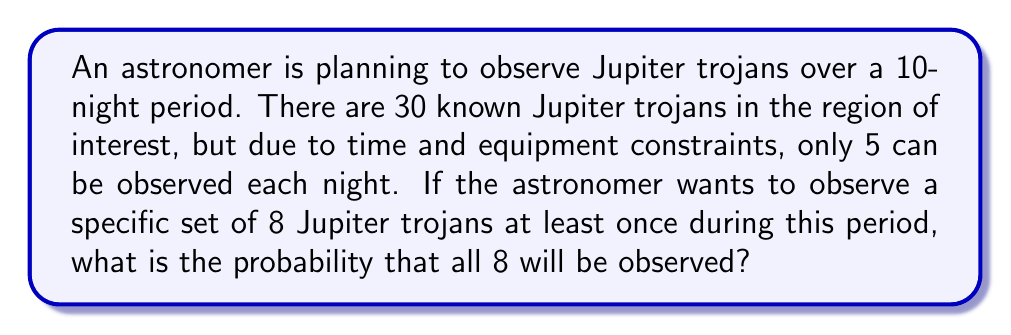Can you answer this question? Let's approach this step-by-step:

1) First, we need to calculate the probability of not observing a specific Jupiter trojan on a given night.
   - There are $\binom{30}{5} = 142,506$ ways to choose 5 trojans out of 30.
   - There are $\binom{29}{5} = 118,755$ ways to choose 5 trojans out of 29 (excluding the specific one).
   - So, the probability of not observing a specific trojan on one night is:
     $$P(\text{not observed}) = \frac{118,755}{142,506} \approx 0.8333$$

2) The probability of not observing this trojan over 10 nights is:
   $$(0.8333)^{10} \approx 0.1615$$

3) Therefore, the probability of observing this trojan at least once in 10 nights is:
   $$1 - 0.1615 = 0.8385$$

4) Now, for all 8 specific trojans to be observed, each of them needs to be observed at least once. These are independent events, so we multiply the probabilities:
   $$(0.8385)^8 \approx 0.2456$$

Thus, the probability of observing all 8 specific Jupiter trojans at least once during the 10-night period is approximately 0.2456 or 24.56%.
Answer: $0.2456$ or $24.56\%$ 